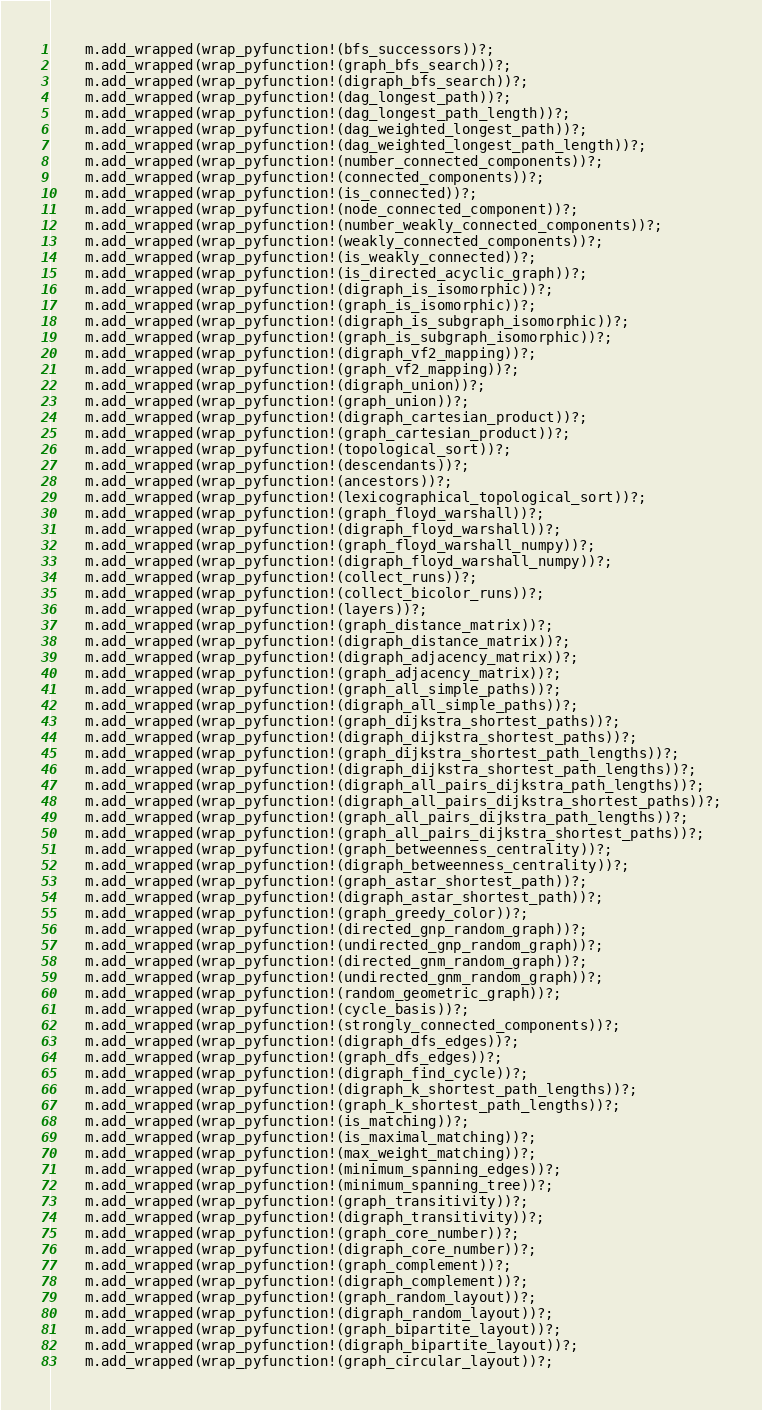<code> <loc_0><loc_0><loc_500><loc_500><_Rust_>    m.add_wrapped(wrap_pyfunction!(bfs_successors))?;
    m.add_wrapped(wrap_pyfunction!(graph_bfs_search))?;
    m.add_wrapped(wrap_pyfunction!(digraph_bfs_search))?;
    m.add_wrapped(wrap_pyfunction!(dag_longest_path))?;
    m.add_wrapped(wrap_pyfunction!(dag_longest_path_length))?;
    m.add_wrapped(wrap_pyfunction!(dag_weighted_longest_path))?;
    m.add_wrapped(wrap_pyfunction!(dag_weighted_longest_path_length))?;
    m.add_wrapped(wrap_pyfunction!(number_connected_components))?;
    m.add_wrapped(wrap_pyfunction!(connected_components))?;
    m.add_wrapped(wrap_pyfunction!(is_connected))?;
    m.add_wrapped(wrap_pyfunction!(node_connected_component))?;
    m.add_wrapped(wrap_pyfunction!(number_weakly_connected_components))?;
    m.add_wrapped(wrap_pyfunction!(weakly_connected_components))?;
    m.add_wrapped(wrap_pyfunction!(is_weakly_connected))?;
    m.add_wrapped(wrap_pyfunction!(is_directed_acyclic_graph))?;
    m.add_wrapped(wrap_pyfunction!(digraph_is_isomorphic))?;
    m.add_wrapped(wrap_pyfunction!(graph_is_isomorphic))?;
    m.add_wrapped(wrap_pyfunction!(digraph_is_subgraph_isomorphic))?;
    m.add_wrapped(wrap_pyfunction!(graph_is_subgraph_isomorphic))?;
    m.add_wrapped(wrap_pyfunction!(digraph_vf2_mapping))?;
    m.add_wrapped(wrap_pyfunction!(graph_vf2_mapping))?;
    m.add_wrapped(wrap_pyfunction!(digraph_union))?;
    m.add_wrapped(wrap_pyfunction!(graph_union))?;
    m.add_wrapped(wrap_pyfunction!(digraph_cartesian_product))?;
    m.add_wrapped(wrap_pyfunction!(graph_cartesian_product))?;
    m.add_wrapped(wrap_pyfunction!(topological_sort))?;
    m.add_wrapped(wrap_pyfunction!(descendants))?;
    m.add_wrapped(wrap_pyfunction!(ancestors))?;
    m.add_wrapped(wrap_pyfunction!(lexicographical_topological_sort))?;
    m.add_wrapped(wrap_pyfunction!(graph_floyd_warshall))?;
    m.add_wrapped(wrap_pyfunction!(digraph_floyd_warshall))?;
    m.add_wrapped(wrap_pyfunction!(graph_floyd_warshall_numpy))?;
    m.add_wrapped(wrap_pyfunction!(digraph_floyd_warshall_numpy))?;
    m.add_wrapped(wrap_pyfunction!(collect_runs))?;
    m.add_wrapped(wrap_pyfunction!(collect_bicolor_runs))?;
    m.add_wrapped(wrap_pyfunction!(layers))?;
    m.add_wrapped(wrap_pyfunction!(graph_distance_matrix))?;
    m.add_wrapped(wrap_pyfunction!(digraph_distance_matrix))?;
    m.add_wrapped(wrap_pyfunction!(digraph_adjacency_matrix))?;
    m.add_wrapped(wrap_pyfunction!(graph_adjacency_matrix))?;
    m.add_wrapped(wrap_pyfunction!(graph_all_simple_paths))?;
    m.add_wrapped(wrap_pyfunction!(digraph_all_simple_paths))?;
    m.add_wrapped(wrap_pyfunction!(graph_dijkstra_shortest_paths))?;
    m.add_wrapped(wrap_pyfunction!(digraph_dijkstra_shortest_paths))?;
    m.add_wrapped(wrap_pyfunction!(graph_dijkstra_shortest_path_lengths))?;
    m.add_wrapped(wrap_pyfunction!(digraph_dijkstra_shortest_path_lengths))?;
    m.add_wrapped(wrap_pyfunction!(digraph_all_pairs_dijkstra_path_lengths))?;
    m.add_wrapped(wrap_pyfunction!(digraph_all_pairs_dijkstra_shortest_paths))?;
    m.add_wrapped(wrap_pyfunction!(graph_all_pairs_dijkstra_path_lengths))?;
    m.add_wrapped(wrap_pyfunction!(graph_all_pairs_dijkstra_shortest_paths))?;
    m.add_wrapped(wrap_pyfunction!(graph_betweenness_centrality))?;
    m.add_wrapped(wrap_pyfunction!(digraph_betweenness_centrality))?;
    m.add_wrapped(wrap_pyfunction!(graph_astar_shortest_path))?;
    m.add_wrapped(wrap_pyfunction!(digraph_astar_shortest_path))?;
    m.add_wrapped(wrap_pyfunction!(graph_greedy_color))?;
    m.add_wrapped(wrap_pyfunction!(directed_gnp_random_graph))?;
    m.add_wrapped(wrap_pyfunction!(undirected_gnp_random_graph))?;
    m.add_wrapped(wrap_pyfunction!(directed_gnm_random_graph))?;
    m.add_wrapped(wrap_pyfunction!(undirected_gnm_random_graph))?;
    m.add_wrapped(wrap_pyfunction!(random_geometric_graph))?;
    m.add_wrapped(wrap_pyfunction!(cycle_basis))?;
    m.add_wrapped(wrap_pyfunction!(strongly_connected_components))?;
    m.add_wrapped(wrap_pyfunction!(digraph_dfs_edges))?;
    m.add_wrapped(wrap_pyfunction!(graph_dfs_edges))?;
    m.add_wrapped(wrap_pyfunction!(digraph_find_cycle))?;
    m.add_wrapped(wrap_pyfunction!(digraph_k_shortest_path_lengths))?;
    m.add_wrapped(wrap_pyfunction!(graph_k_shortest_path_lengths))?;
    m.add_wrapped(wrap_pyfunction!(is_matching))?;
    m.add_wrapped(wrap_pyfunction!(is_maximal_matching))?;
    m.add_wrapped(wrap_pyfunction!(max_weight_matching))?;
    m.add_wrapped(wrap_pyfunction!(minimum_spanning_edges))?;
    m.add_wrapped(wrap_pyfunction!(minimum_spanning_tree))?;
    m.add_wrapped(wrap_pyfunction!(graph_transitivity))?;
    m.add_wrapped(wrap_pyfunction!(digraph_transitivity))?;
    m.add_wrapped(wrap_pyfunction!(graph_core_number))?;
    m.add_wrapped(wrap_pyfunction!(digraph_core_number))?;
    m.add_wrapped(wrap_pyfunction!(graph_complement))?;
    m.add_wrapped(wrap_pyfunction!(digraph_complement))?;
    m.add_wrapped(wrap_pyfunction!(graph_random_layout))?;
    m.add_wrapped(wrap_pyfunction!(digraph_random_layout))?;
    m.add_wrapped(wrap_pyfunction!(graph_bipartite_layout))?;
    m.add_wrapped(wrap_pyfunction!(digraph_bipartite_layout))?;
    m.add_wrapped(wrap_pyfunction!(graph_circular_layout))?;</code> 